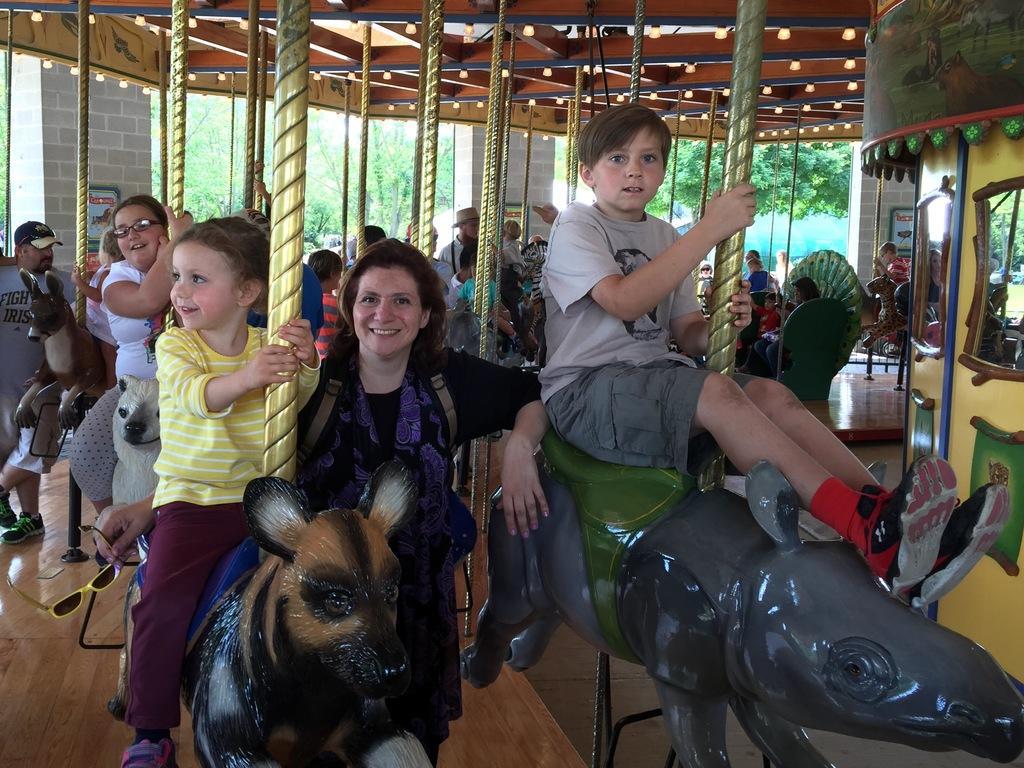In one or two sentences, can you explain what this image depicts? in this picture the big hall is there and so many people they are sitting on the toys and some of the children are playing the toys behind there is some trees are there the background is greenery 